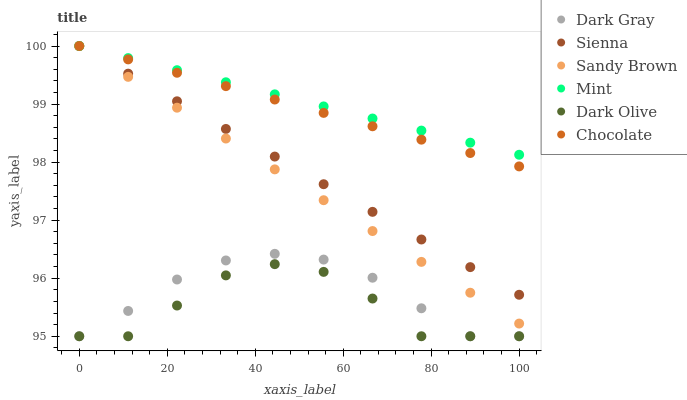Does Dark Olive have the minimum area under the curve?
Answer yes or no. Yes. Does Mint have the maximum area under the curve?
Answer yes or no. Yes. Does Mint have the minimum area under the curve?
Answer yes or no. No. Does Dark Olive have the maximum area under the curve?
Answer yes or no. No. Is Sandy Brown the smoothest?
Answer yes or no. Yes. Is Dark Olive the roughest?
Answer yes or no. Yes. Is Mint the smoothest?
Answer yes or no. No. Is Mint the roughest?
Answer yes or no. No. Does Dark Olive have the lowest value?
Answer yes or no. Yes. Does Mint have the lowest value?
Answer yes or no. No. Does Sandy Brown have the highest value?
Answer yes or no. Yes. Does Dark Olive have the highest value?
Answer yes or no. No. Is Dark Olive less than Sienna?
Answer yes or no. Yes. Is Sienna greater than Dark Gray?
Answer yes or no. Yes. Does Sandy Brown intersect Sienna?
Answer yes or no. Yes. Is Sandy Brown less than Sienna?
Answer yes or no. No. Is Sandy Brown greater than Sienna?
Answer yes or no. No. Does Dark Olive intersect Sienna?
Answer yes or no. No. 